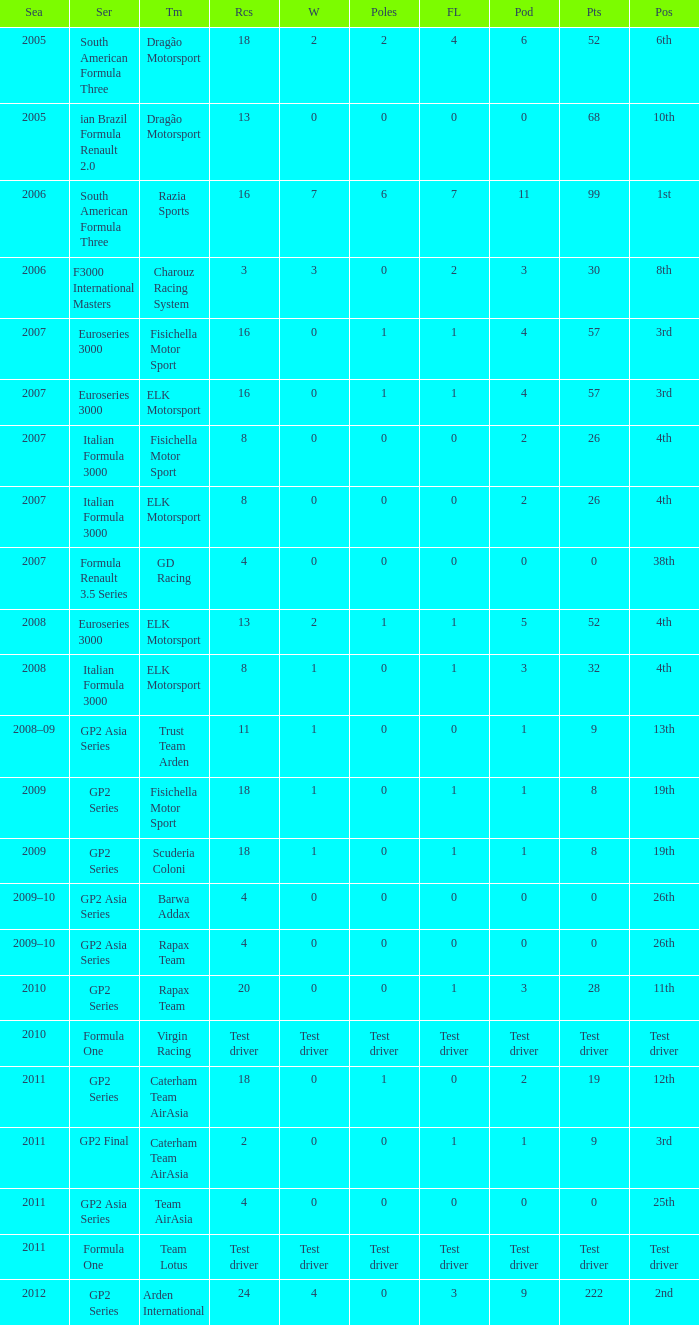In which season did he have 0 Poles and 19th position in the GP2 Series? 2009, 2009. 